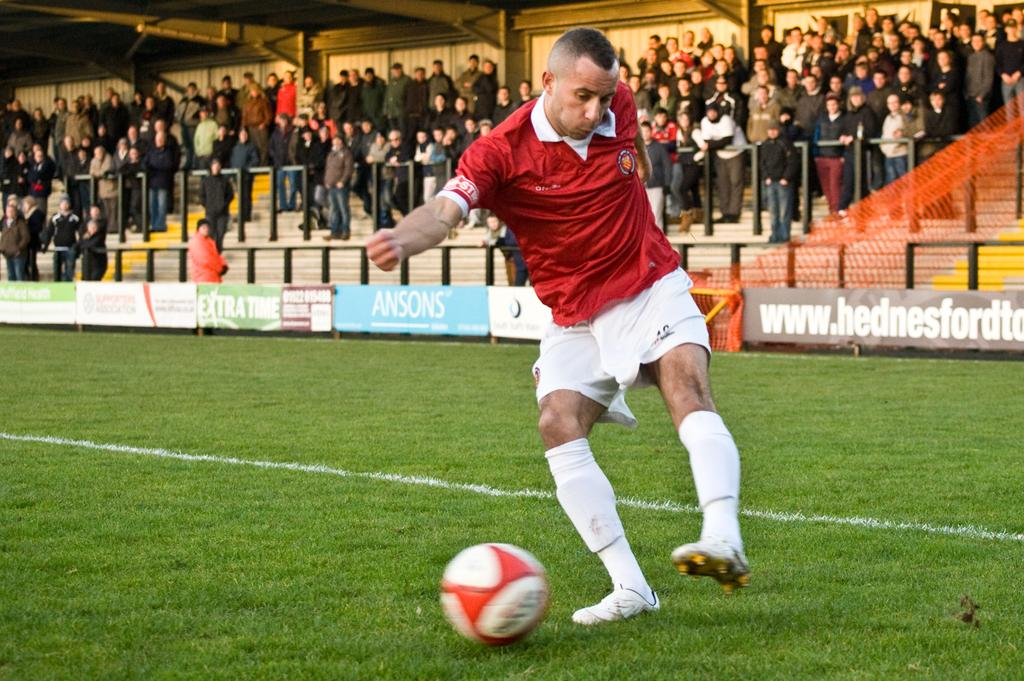<image>
Summarize the visual content of the image. Soccer player kicking a ball in front of an ad for ANSONS. 